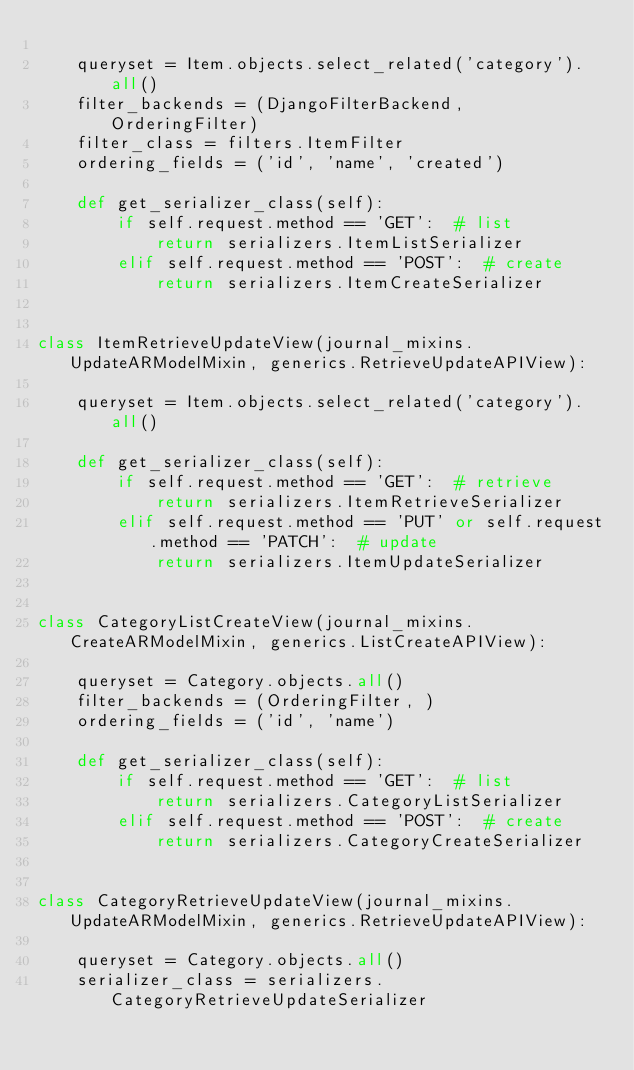Convert code to text. <code><loc_0><loc_0><loc_500><loc_500><_Python_>
    queryset = Item.objects.select_related('category').all()
    filter_backends = (DjangoFilterBackend, OrderingFilter)
    filter_class = filters.ItemFilter
    ordering_fields = ('id', 'name', 'created')

    def get_serializer_class(self):
        if self.request.method == 'GET':  # list
            return serializers.ItemListSerializer
        elif self.request.method == 'POST':  # create
            return serializers.ItemCreateSerializer


class ItemRetrieveUpdateView(journal_mixins.UpdateARModelMixin, generics.RetrieveUpdateAPIView):

    queryset = Item.objects.select_related('category').all()

    def get_serializer_class(self):
        if self.request.method == 'GET':  # retrieve
            return serializers.ItemRetrieveSerializer
        elif self.request.method == 'PUT' or self.request.method == 'PATCH':  # update
            return serializers.ItemUpdateSerializer


class CategoryListCreateView(journal_mixins.CreateARModelMixin, generics.ListCreateAPIView):

    queryset = Category.objects.all()
    filter_backends = (OrderingFilter, )
    ordering_fields = ('id', 'name')

    def get_serializer_class(self):
        if self.request.method == 'GET':  # list
            return serializers.CategoryListSerializer
        elif self.request.method == 'POST':  # create
            return serializers.CategoryCreateSerializer


class CategoryRetrieveUpdateView(journal_mixins.UpdateARModelMixin, generics.RetrieveUpdateAPIView):

    queryset = Category.objects.all()
    serializer_class = serializers.CategoryRetrieveUpdateSerializer

</code> 